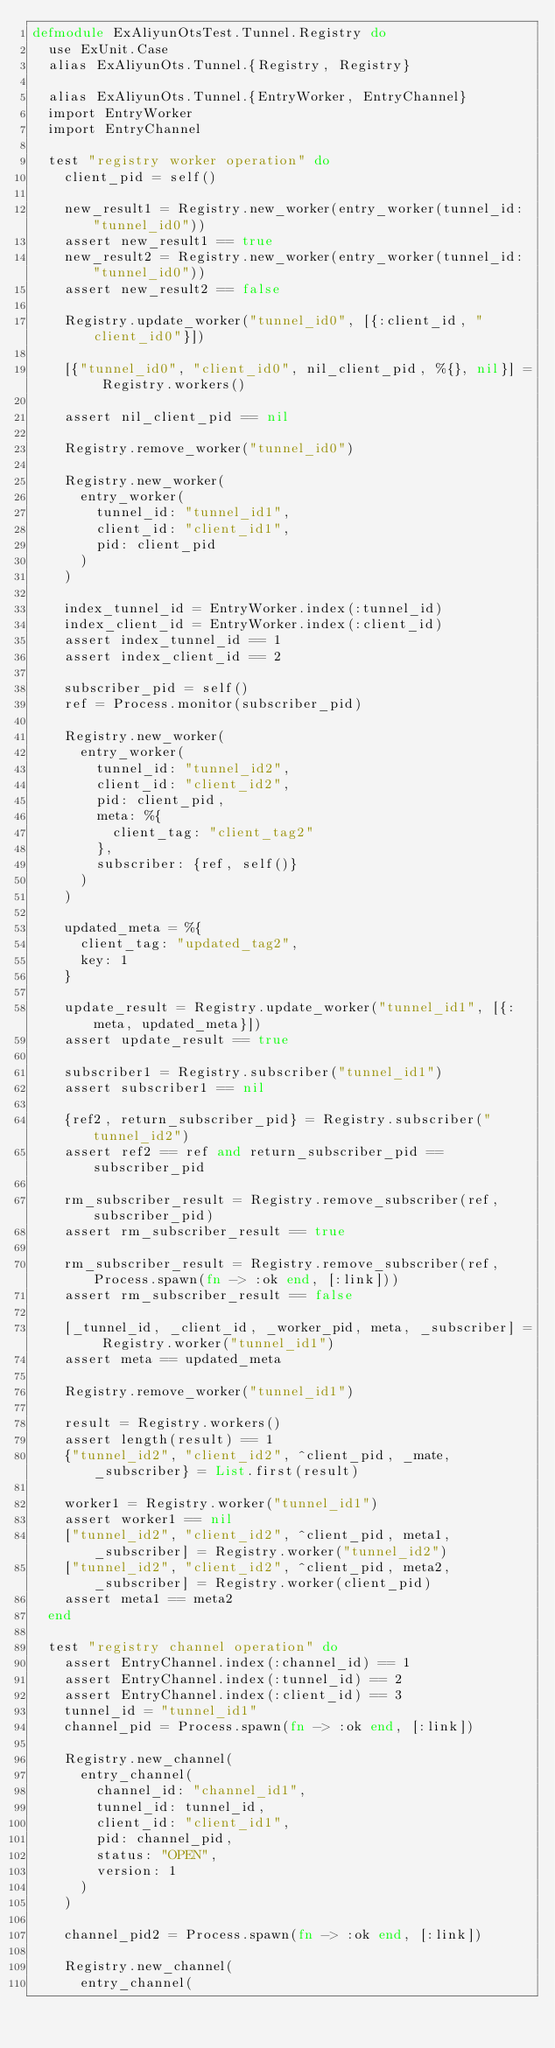<code> <loc_0><loc_0><loc_500><loc_500><_Elixir_>defmodule ExAliyunOtsTest.Tunnel.Registry do
  use ExUnit.Case
  alias ExAliyunOts.Tunnel.{Registry, Registry}

  alias ExAliyunOts.Tunnel.{EntryWorker, EntryChannel}
  import EntryWorker
  import EntryChannel

  test "registry worker operation" do
    client_pid = self()

    new_result1 = Registry.new_worker(entry_worker(tunnel_id: "tunnel_id0"))
    assert new_result1 == true
    new_result2 = Registry.new_worker(entry_worker(tunnel_id: "tunnel_id0"))
    assert new_result2 == false

    Registry.update_worker("tunnel_id0", [{:client_id, "client_id0"}])

    [{"tunnel_id0", "client_id0", nil_client_pid, %{}, nil}] = Registry.workers()

    assert nil_client_pid == nil

    Registry.remove_worker("tunnel_id0")

    Registry.new_worker(
      entry_worker(
        tunnel_id: "tunnel_id1",
        client_id: "client_id1",
        pid: client_pid
      )
    )

    index_tunnel_id = EntryWorker.index(:tunnel_id)
    index_client_id = EntryWorker.index(:client_id)
    assert index_tunnel_id == 1
    assert index_client_id == 2

    subscriber_pid = self()
    ref = Process.monitor(subscriber_pid)

    Registry.new_worker(
      entry_worker(
        tunnel_id: "tunnel_id2",
        client_id: "client_id2",
        pid: client_pid,
        meta: %{
          client_tag: "client_tag2"
        },
        subscriber: {ref, self()}
      )
    )

    updated_meta = %{
      client_tag: "updated_tag2",
      key: 1
    }

    update_result = Registry.update_worker("tunnel_id1", [{:meta, updated_meta}])
    assert update_result == true

    subscriber1 = Registry.subscriber("tunnel_id1")
    assert subscriber1 == nil

    {ref2, return_subscriber_pid} = Registry.subscriber("tunnel_id2")
    assert ref2 == ref and return_subscriber_pid == subscriber_pid

    rm_subscriber_result = Registry.remove_subscriber(ref, subscriber_pid)
    assert rm_subscriber_result == true

    rm_subscriber_result = Registry.remove_subscriber(ref, Process.spawn(fn -> :ok end, [:link]))
    assert rm_subscriber_result == false

    [_tunnel_id, _client_id, _worker_pid, meta, _subscriber] = Registry.worker("tunnel_id1")
    assert meta == updated_meta

    Registry.remove_worker("tunnel_id1")

    result = Registry.workers()
    assert length(result) == 1
    {"tunnel_id2", "client_id2", ^client_pid, _mate, _subscriber} = List.first(result)

    worker1 = Registry.worker("tunnel_id1")
    assert worker1 == nil
    ["tunnel_id2", "client_id2", ^client_pid, meta1, _subscriber] = Registry.worker("tunnel_id2")
    ["tunnel_id2", "client_id2", ^client_pid, meta2, _subscriber] = Registry.worker(client_pid)
    assert meta1 == meta2
  end

  test "registry channel operation" do
    assert EntryChannel.index(:channel_id) == 1
    assert EntryChannel.index(:tunnel_id) == 2
    assert EntryChannel.index(:client_id) == 3
    tunnel_id = "tunnel_id1"
    channel_pid = Process.spawn(fn -> :ok end, [:link])

    Registry.new_channel(
      entry_channel(
        channel_id: "channel_id1",
        tunnel_id: tunnel_id,
        client_id: "client_id1",
        pid: channel_pid,
        status: "OPEN",
        version: 1
      )
    )

    channel_pid2 = Process.spawn(fn -> :ok end, [:link])

    Registry.new_channel(
      entry_channel(</code> 